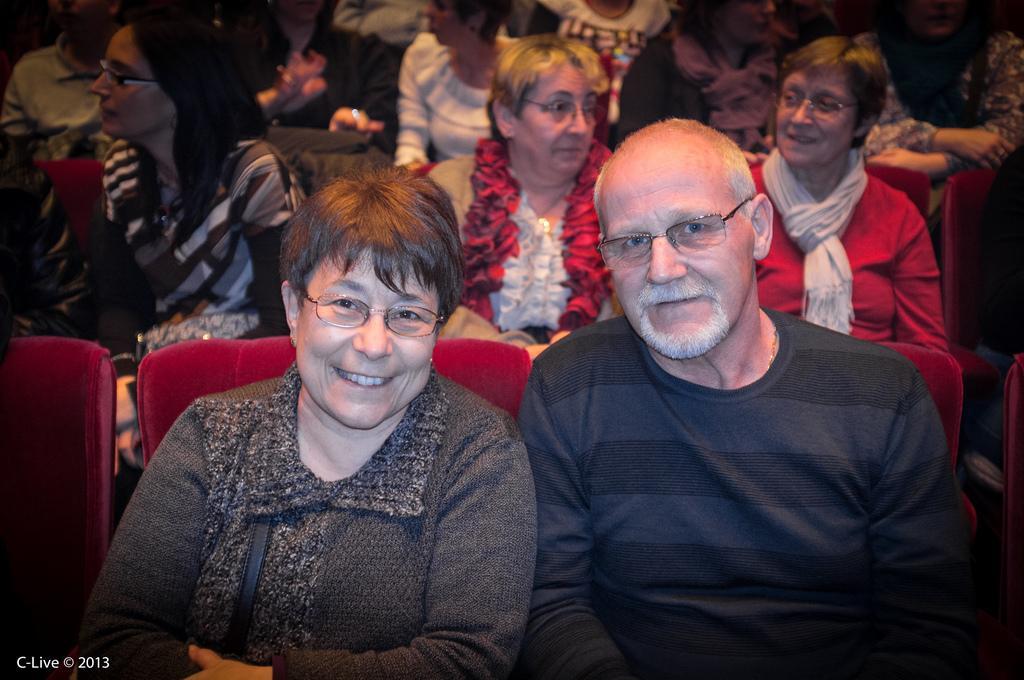Please provide a concise description of this image. In the image we can see there are many people wearing clothes, they are sitting on the chair, these people are wearing spectacles. These people are smiling and this is a watermark. 